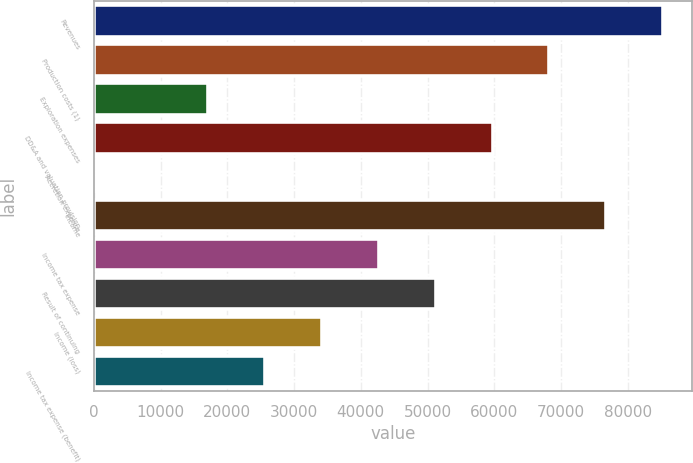Convert chart. <chart><loc_0><loc_0><loc_500><loc_500><bar_chart><fcel>Revenues<fcel>Production costs (1)<fcel>Exploration expenses<fcel>DD&A and valuation provision<fcel>Accretion expense<fcel>Income<fcel>Income tax expense<fcel>Result of continuing<fcel>Income (loss)<fcel>Income tax expense (benefit)<nl><fcel>85328<fcel>68266.8<fcel>17083.2<fcel>59736.2<fcel>22<fcel>76797.4<fcel>42675<fcel>51205.6<fcel>34144.4<fcel>25613.8<nl></chart> 